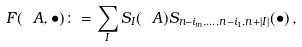Convert formula to latex. <formula><loc_0><loc_0><loc_500><loc_500>F ( \ A , \bullet ) \colon = \sum _ { I } S _ { I } ( \ A ) S _ { n - i _ { m } , \dots , n - i _ { 1 } , n + | I | } ( \bullet ) \, ,</formula> 